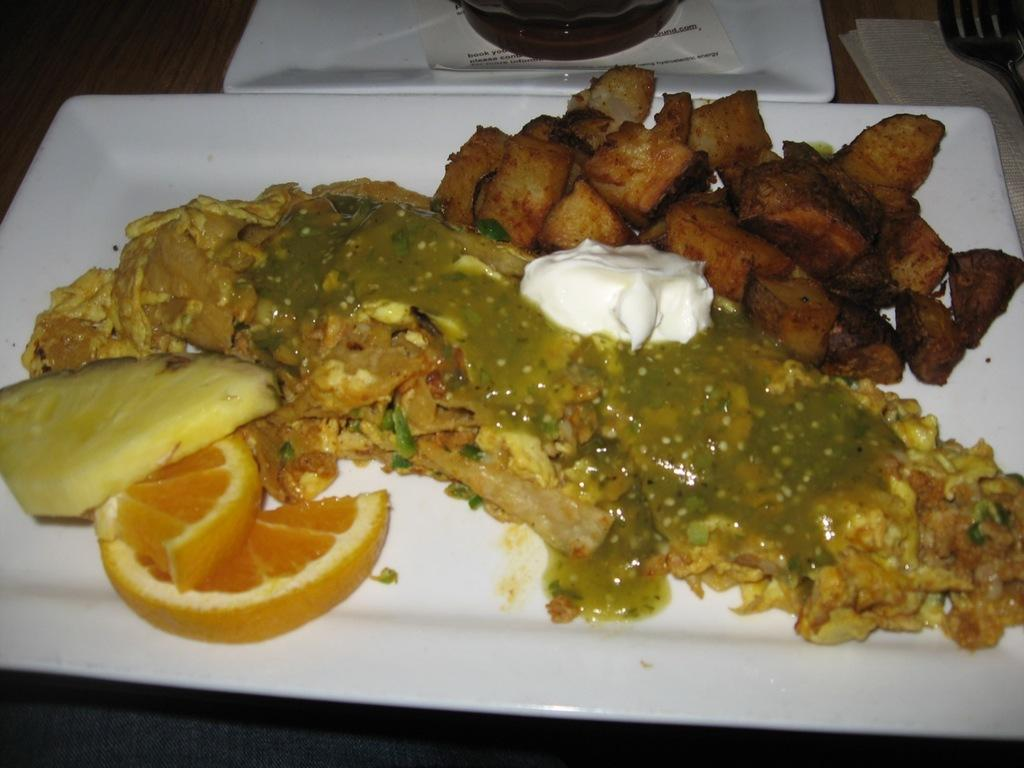What objects are present in the image that are typically used for eating? There are plates, forks, and paper in the image, which are commonly used for eating. What else can be seen in the image besides utensils and plates? There is food in the image. What hobbies are the people in the image participating in? There is no indication of people or hobbies in the image; it only shows plates, paper, forks, and food. Can you tell me where the sack is located in the image? There is no sack present in the image. 